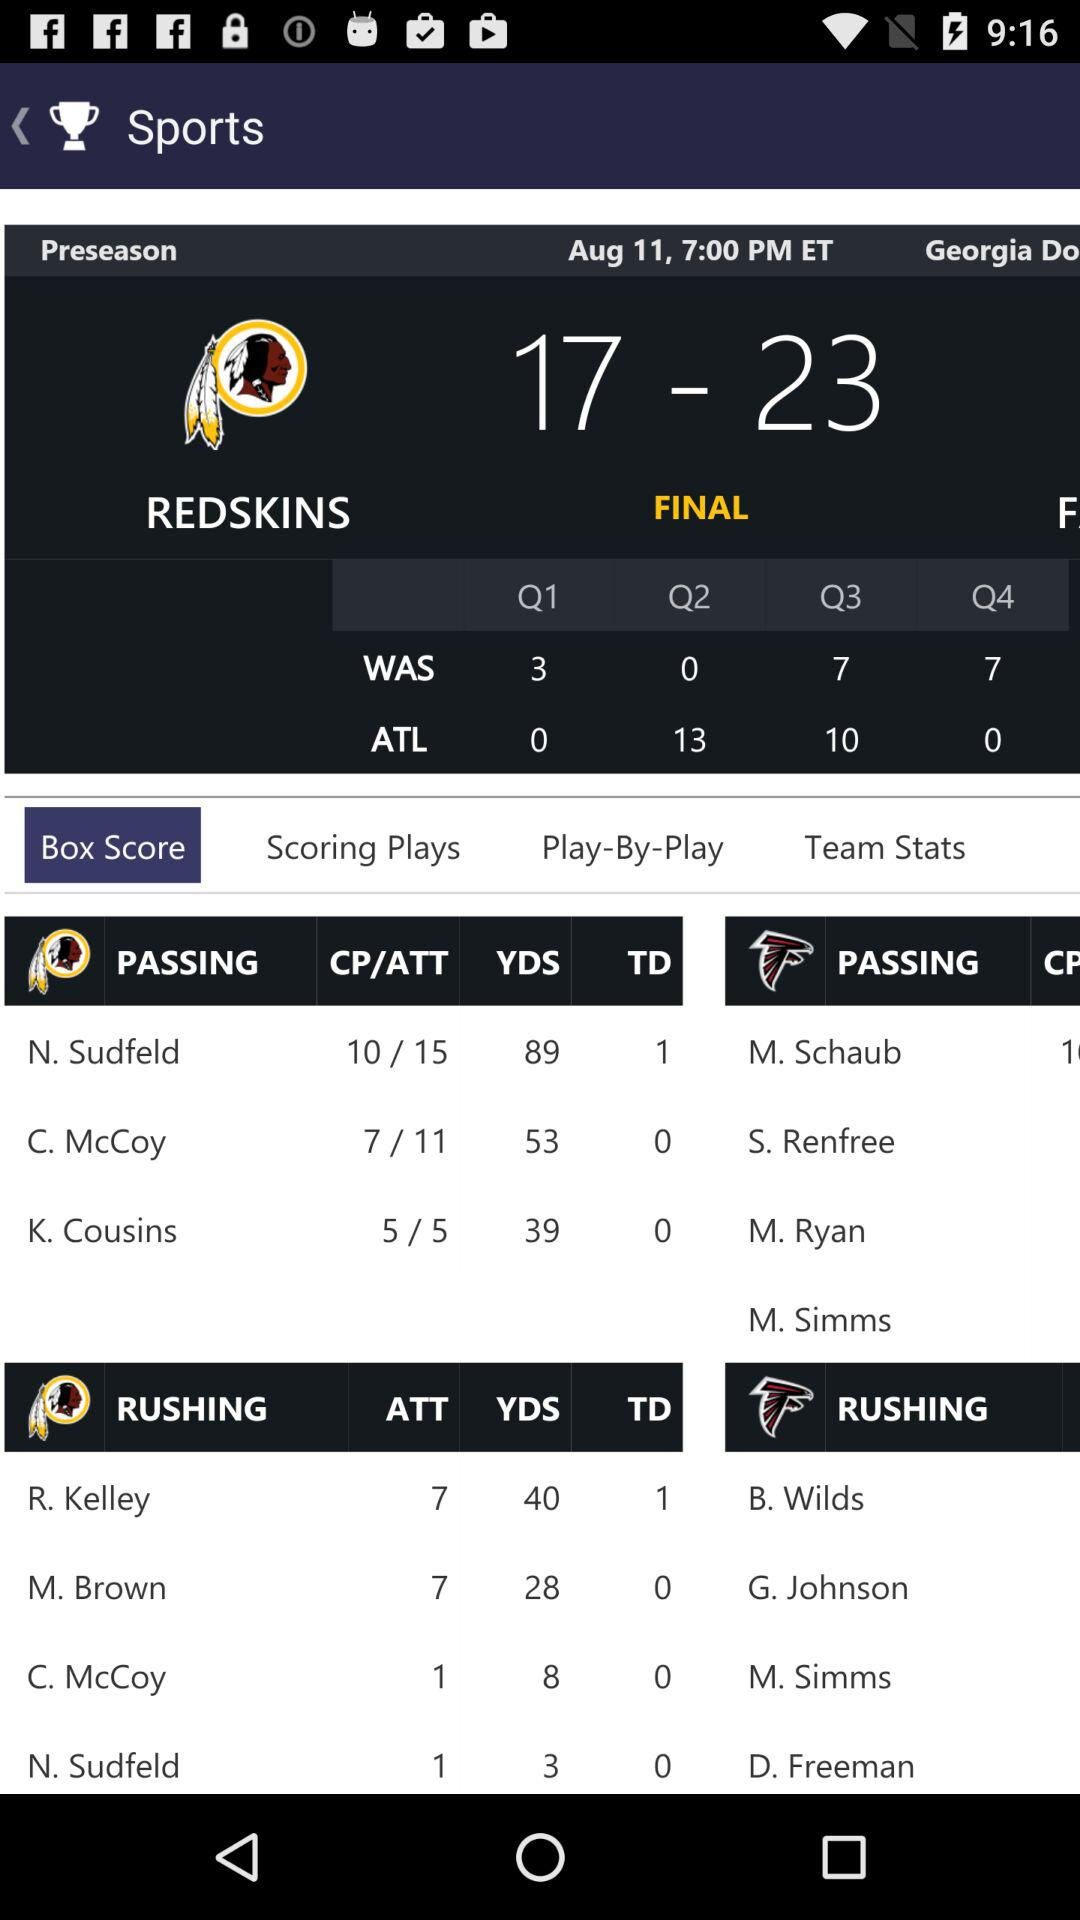What is the number of passing yards for N. Sudfeld? The number of passing yards is 89. 